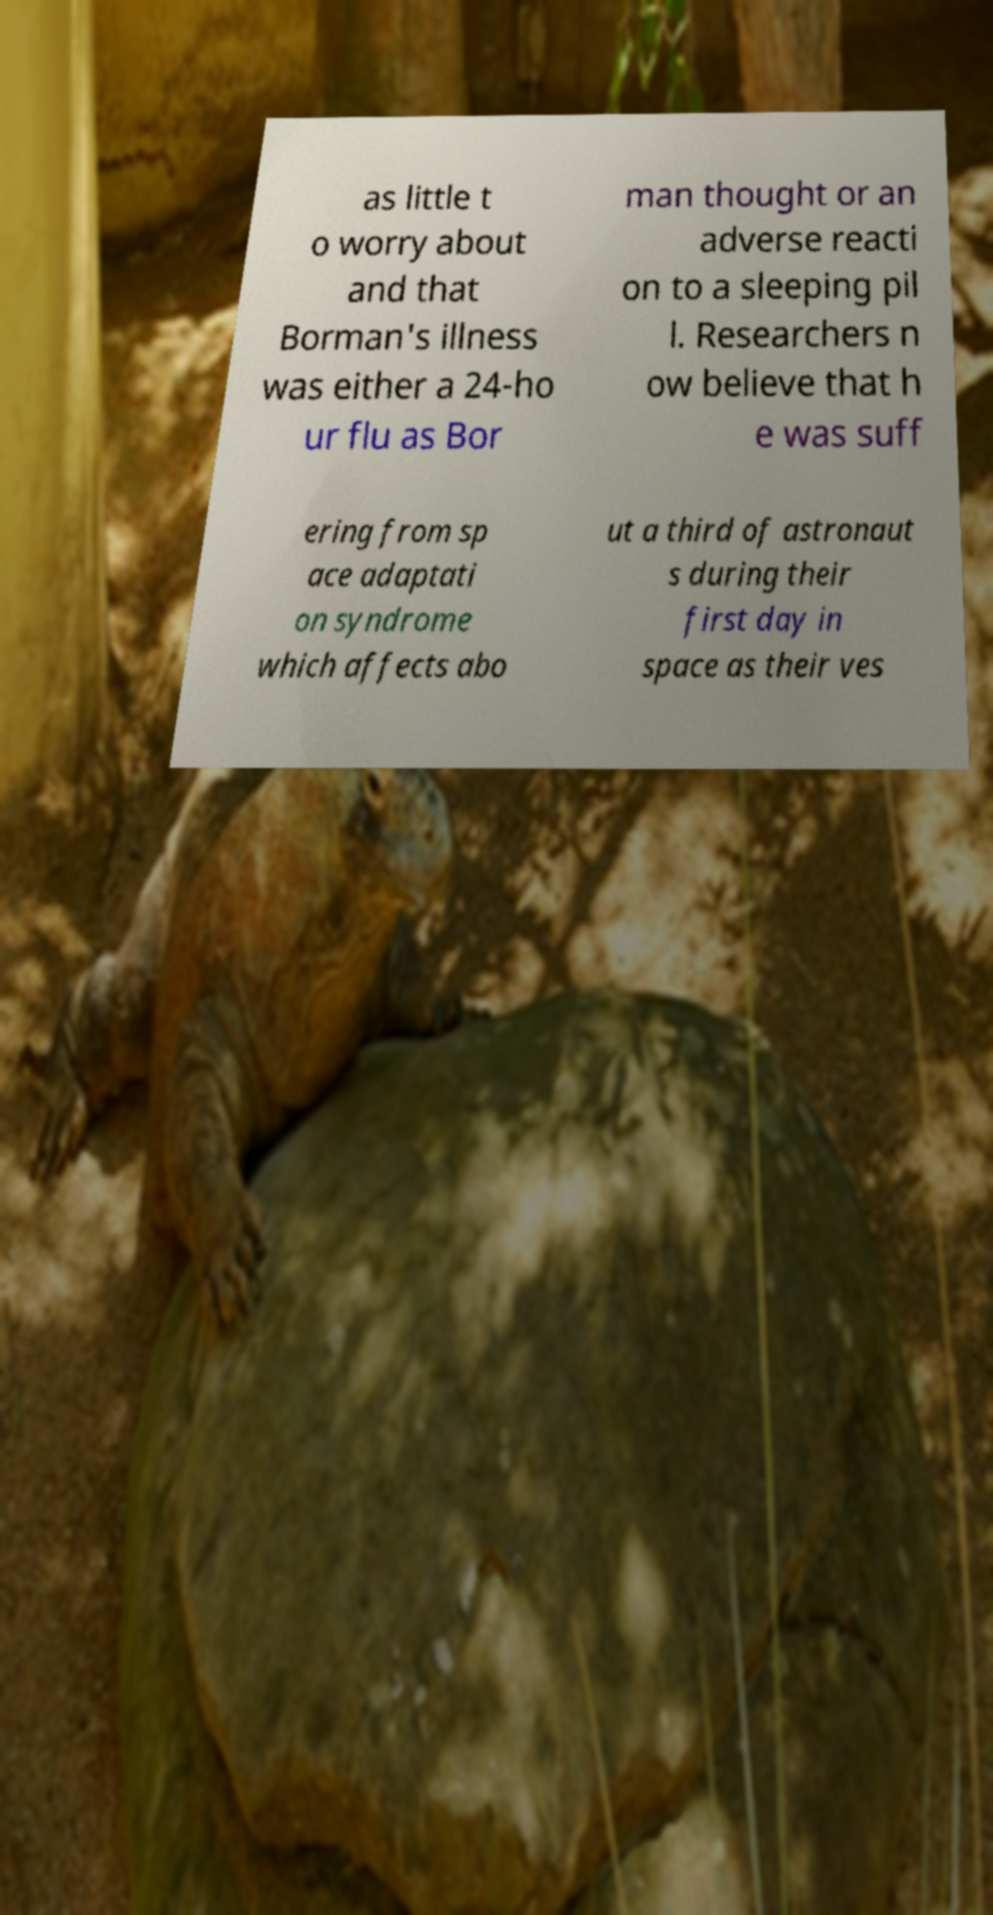For documentation purposes, I need the text within this image transcribed. Could you provide that? as little t o worry about and that Borman's illness was either a 24-ho ur flu as Bor man thought or an adverse reacti on to a sleeping pil l. Researchers n ow believe that h e was suff ering from sp ace adaptati on syndrome which affects abo ut a third of astronaut s during their first day in space as their ves 